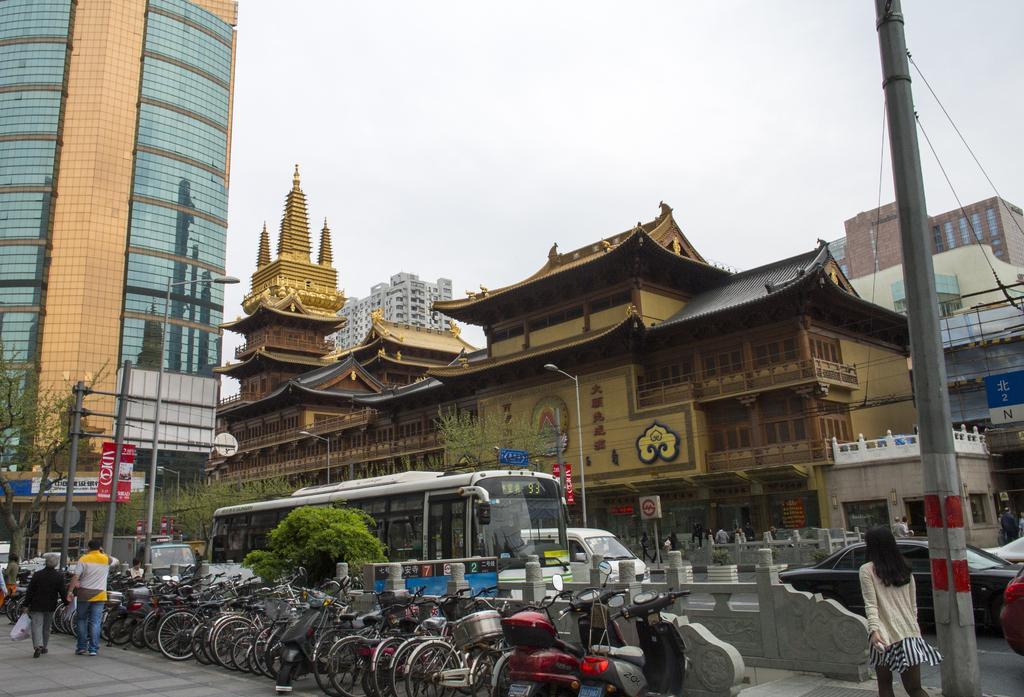Please provide a concise description of this image. In the picture we can see a street, in the street we can see a path with some bicycles are parked near the path and we can also see some plant and on the road we can see some vehicles like cars, buses and in the background we can see some buildings and a sky. 